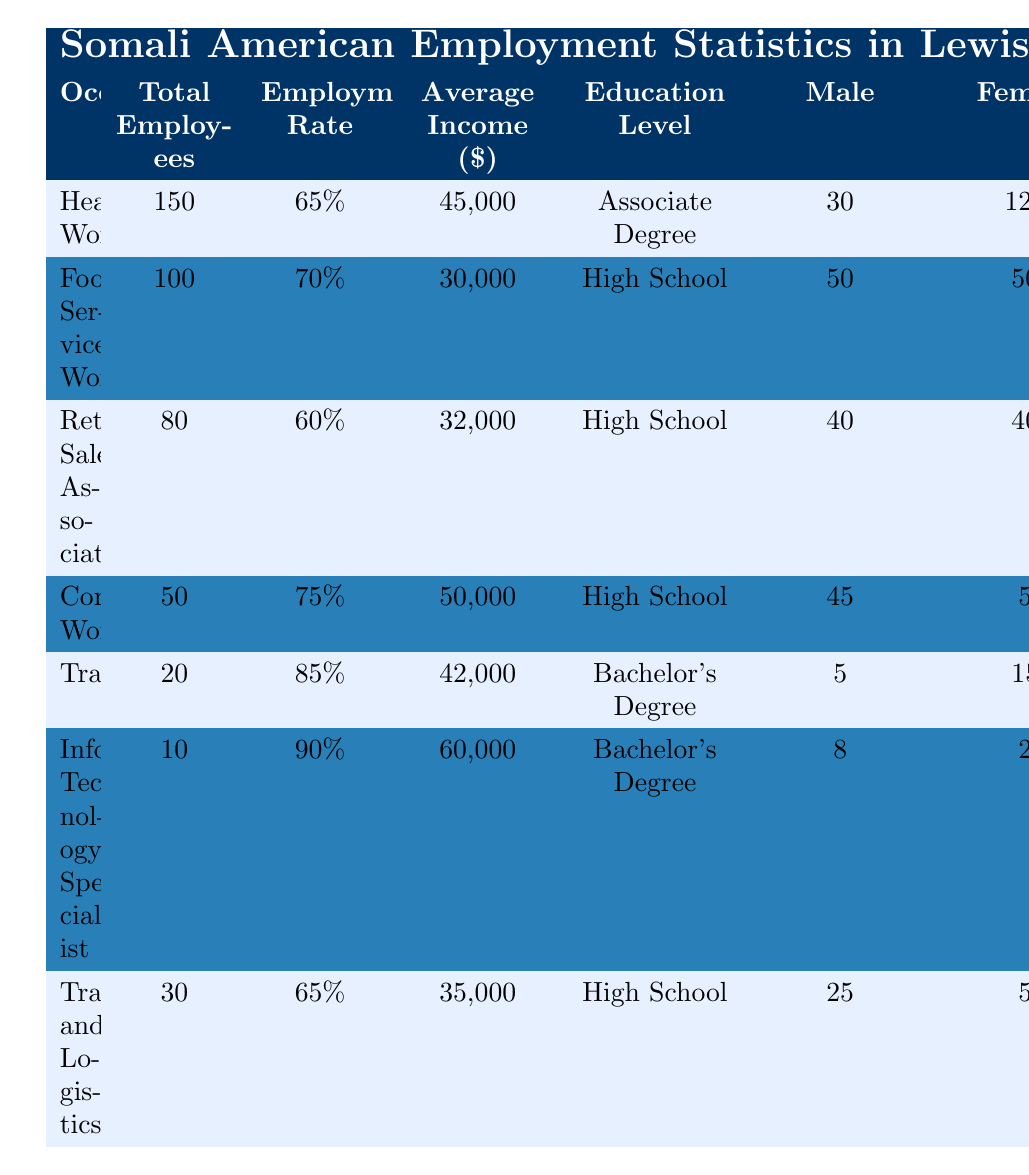How many Healthcare Workers are employed in Lewiston? According to the table, the Total Employees for the occupation of Healthcare Worker is listed as 150.
Answer: 150 What is the average income for Food Service Workers? The table shows that the Average Income for Food Service Workers is $30,000.
Answer: $30,000 What is the employment rate for Retail Sales Associates? The Employment Rate for Retail Sales Associates is stated as 60% in the table.
Answer: 60% How many female Construction Workers are there? The table indicates that there are 5 females employed as Construction Workers.
Answer: 5 What is the total number of employees across all occupations listed? To find the total number of employees, add the Total Employees from each occupation: 150 + 100 + 80 + 50 + 20 + 10 + 30 = 440.
Answer: 440 What is the average income for all the listed jobs? Calculate the total income: (45,000 + 30,000 + 32,000 + 50,000 + 42,000 + 60,000 + 35,000) = 294,000. Divide by the number of occupations (7): 294,000 / 7 = 42,000.
Answer: $42,000 Is the average income for Information Technology Specialists higher than that of Healthcare Workers? According to the table, the Average Income for Information Technology Specialists ($60,000) is greater than that for Healthcare Workers ($45,000), so the statement is true.
Answer: Yes Which occupation has the highest employment rate? The table shows that Information Technology Specialists have the highest Employment Rate at 90%.
Answer: 90% What percentage of Healthcare Workers are female? In the Healthcare Worker category, there are 120 females out of a total of 150 employees. To find the percentage, calculate (120 / 150) * 100 = 80%.
Answer: 80% How many more males are employed in Transportation and Logistics compared to Translators/Interpreters? The table indicates that there are 25 males in Transportation and Logistics and 5 males in Translators/Interpreters. The difference is 25 - 5 = 20 more males.
Answer: 20 